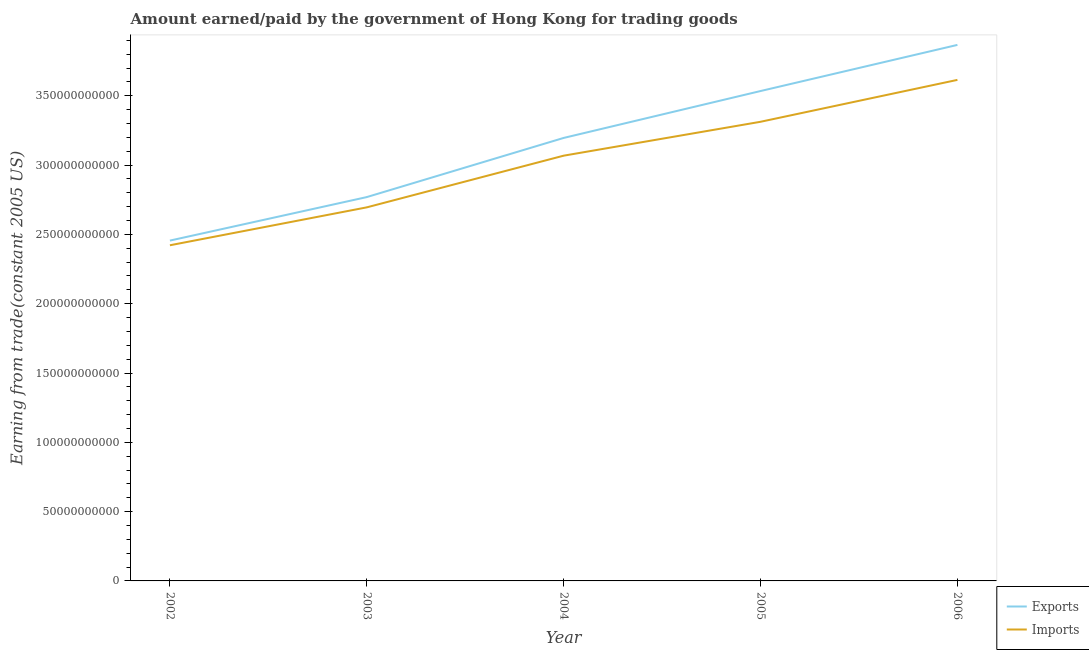How many different coloured lines are there?
Your response must be concise. 2. What is the amount paid for imports in 2004?
Provide a succinct answer. 3.07e+11. Across all years, what is the maximum amount earned from exports?
Your answer should be compact. 3.87e+11. Across all years, what is the minimum amount earned from exports?
Your answer should be compact. 2.46e+11. In which year was the amount earned from exports maximum?
Provide a succinct answer. 2006. What is the total amount paid for imports in the graph?
Offer a terse response. 1.51e+12. What is the difference between the amount paid for imports in 2004 and that in 2006?
Your answer should be compact. -5.47e+1. What is the difference between the amount paid for imports in 2003 and the amount earned from exports in 2002?
Your answer should be compact. 2.40e+1. What is the average amount paid for imports per year?
Ensure brevity in your answer.  3.02e+11. In the year 2006, what is the difference between the amount paid for imports and amount earned from exports?
Provide a succinct answer. -2.52e+1. In how many years, is the amount earned from exports greater than 330000000000 US$?
Offer a very short reply. 2. What is the ratio of the amount paid for imports in 2003 to that in 2004?
Keep it short and to the point. 0.88. Is the amount earned from exports in 2002 less than that in 2005?
Make the answer very short. Yes. What is the difference between the highest and the second highest amount paid for imports?
Ensure brevity in your answer.  3.02e+1. What is the difference between the highest and the lowest amount earned from exports?
Your response must be concise. 1.41e+11. Is the amount paid for imports strictly greater than the amount earned from exports over the years?
Make the answer very short. No. Is the amount earned from exports strictly less than the amount paid for imports over the years?
Ensure brevity in your answer.  No. How many lines are there?
Your response must be concise. 2. How many years are there in the graph?
Provide a succinct answer. 5. Are the values on the major ticks of Y-axis written in scientific E-notation?
Provide a short and direct response. No. Where does the legend appear in the graph?
Offer a very short reply. Bottom right. What is the title of the graph?
Provide a succinct answer. Amount earned/paid by the government of Hong Kong for trading goods. What is the label or title of the X-axis?
Provide a short and direct response. Year. What is the label or title of the Y-axis?
Offer a very short reply. Earning from trade(constant 2005 US). What is the Earning from trade(constant 2005 US) of Exports in 2002?
Offer a very short reply. 2.46e+11. What is the Earning from trade(constant 2005 US) in Imports in 2002?
Give a very brief answer. 2.42e+11. What is the Earning from trade(constant 2005 US) of Exports in 2003?
Keep it short and to the point. 2.77e+11. What is the Earning from trade(constant 2005 US) in Imports in 2003?
Offer a very short reply. 2.70e+11. What is the Earning from trade(constant 2005 US) of Exports in 2004?
Offer a terse response. 3.20e+11. What is the Earning from trade(constant 2005 US) of Imports in 2004?
Your answer should be very brief. 3.07e+11. What is the Earning from trade(constant 2005 US) of Exports in 2005?
Provide a short and direct response. 3.53e+11. What is the Earning from trade(constant 2005 US) of Imports in 2005?
Provide a short and direct response. 3.31e+11. What is the Earning from trade(constant 2005 US) in Exports in 2006?
Provide a succinct answer. 3.87e+11. What is the Earning from trade(constant 2005 US) in Imports in 2006?
Provide a succinct answer. 3.61e+11. Across all years, what is the maximum Earning from trade(constant 2005 US) of Exports?
Offer a terse response. 3.87e+11. Across all years, what is the maximum Earning from trade(constant 2005 US) in Imports?
Your answer should be very brief. 3.61e+11. Across all years, what is the minimum Earning from trade(constant 2005 US) in Exports?
Your answer should be compact. 2.46e+11. Across all years, what is the minimum Earning from trade(constant 2005 US) in Imports?
Give a very brief answer. 2.42e+11. What is the total Earning from trade(constant 2005 US) in Exports in the graph?
Your answer should be very brief. 1.58e+12. What is the total Earning from trade(constant 2005 US) of Imports in the graph?
Your response must be concise. 1.51e+12. What is the difference between the Earning from trade(constant 2005 US) in Exports in 2002 and that in 2003?
Your response must be concise. -3.14e+1. What is the difference between the Earning from trade(constant 2005 US) of Imports in 2002 and that in 2003?
Provide a short and direct response. -2.74e+1. What is the difference between the Earning from trade(constant 2005 US) in Exports in 2002 and that in 2004?
Make the answer very short. -7.41e+1. What is the difference between the Earning from trade(constant 2005 US) of Imports in 2002 and that in 2004?
Keep it short and to the point. -6.46e+1. What is the difference between the Earning from trade(constant 2005 US) in Exports in 2002 and that in 2005?
Offer a very short reply. -1.08e+11. What is the difference between the Earning from trade(constant 2005 US) in Imports in 2002 and that in 2005?
Provide a succinct answer. -8.91e+1. What is the difference between the Earning from trade(constant 2005 US) in Exports in 2002 and that in 2006?
Give a very brief answer. -1.41e+11. What is the difference between the Earning from trade(constant 2005 US) of Imports in 2002 and that in 2006?
Make the answer very short. -1.19e+11. What is the difference between the Earning from trade(constant 2005 US) of Exports in 2003 and that in 2004?
Your answer should be very brief. -4.27e+1. What is the difference between the Earning from trade(constant 2005 US) of Imports in 2003 and that in 2004?
Give a very brief answer. -3.73e+1. What is the difference between the Earning from trade(constant 2005 US) in Exports in 2003 and that in 2005?
Ensure brevity in your answer.  -7.65e+1. What is the difference between the Earning from trade(constant 2005 US) of Imports in 2003 and that in 2005?
Provide a succinct answer. -6.17e+1. What is the difference between the Earning from trade(constant 2005 US) in Exports in 2003 and that in 2006?
Your answer should be very brief. -1.10e+11. What is the difference between the Earning from trade(constant 2005 US) in Imports in 2003 and that in 2006?
Your response must be concise. -9.20e+1. What is the difference between the Earning from trade(constant 2005 US) of Exports in 2004 and that in 2005?
Your response must be concise. -3.38e+1. What is the difference between the Earning from trade(constant 2005 US) in Imports in 2004 and that in 2005?
Your answer should be very brief. -2.45e+1. What is the difference between the Earning from trade(constant 2005 US) in Exports in 2004 and that in 2006?
Keep it short and to the point. -6.71e+1. What is the difference between the Earning from trade(constant 2005 US) in Imports in 2004 and that in 2006?
Keep it short and to the point. -5.47e+1. What is the difference between the Earning from trade(constant 2005 US) in Exports in 2005 and that in 2006?
Keep it short and to the point. -3.33e+1. What is the difference between the Earning from trade(constant 2005 US) of Imports in 2005 and that in 2006?
Offer a very short reply. -3.02e+1. What is the difference between the Earning from trade(constant 2005 US) in Exports in 2002 and the Earning from trade(constant 2005 US) in Imports in 2003?
Your answer should be compact. -2.40e+1. What is the difference between the Earning from trade(constant 2005 US) in Exports in 2002 and the Earning from trade(constant 2005 US) in Imports in 2004?
Offer a very short reply. -6.13e+1. What is the difference between the Earning from trade(constant 2005 US) of Exports in 2002 and the Earning from trade(constant 2005 US) of Imports in 2005?
Ensure brevity in your answer.  -8.57e+1. What is the difference between the Earning from trade(constant 2005 US) of Exports in 2002 and the Earning from trade(constant 2005 US) of Imports in 2006?
Make the answer very short. -1.16e+11. What is the difference between the Earning from trade(constant 2005 US) of Exports in 2003 and the Earning from trade(constant 2005 US) of Imports in 2004?
Provide a short and direct response. -2.99e+1. What is the difference between the Earning from trade(constant 2005 US) of Exports in 2003 and the Earning from trade(constant 2005 US) of Imports in 2005?
Ensure brevity in your answer.  -5.43e+1. What is the difference between the Earning from trade(constant 2005 US) of Exports in 2003 and the Earning from trade(constant 2005 US) of Imports in 2006?
Your answer should be very brief. -8.45e+1. What is the difference between the Earning from trade(constant 2005 US) in Exports in 2004 and the Earning from trade(constant 2005 US) in Imports in 2005?
Provide a short and direct response. -1.17e+1. What is the difference between the Earning from trade(constant 2005 US) of Exports in 2004 and the Earning from trade(constant 2005 US) of Imports in 2006?
Give a very brief answer. -4.19e+1. What is the difference between the Earning from trade(constant 2005 US) of Exports in 2005 and the Earning from trade(constant 2005 US) of Imports in 2006?
Offer a terse response. -8.04e+09. What is the average Earning from trade(constant 2005 US) of Exports per year?
Offer a terse response. 3.16e+11. What is the average Earning from trade(constant 2005 US) in Imports per year?
Provide a short and direct response. 3.02e+11. In the year 2002, what is the difference between the Earning from trade(constant 2005 US) in Exports and Earning from trade(constant 2005 US) in Imports?
Make the answer very short. 3.38e+09. In the year 2003, what is the difference between the Earning from trade(constant 2005 US) of Exports and Earning from trade(constant 2005 US) of Imports?
Provide a succinct answer. 7.41e+09. In the year 2004, what is the difference between the Earning from trade(constant 2005 US) of Exports and Earning from trade(constant 2005 US) of Imports?
Keep it short and to the point. 1.28e+1. In the year 2005, what is the difference between the Earning from trade(constant 2005 US) of Exports and Earning from trade(constant 2005 US) of Imports?
Make the answer very short. 2.22e+1. In the year 2006, what is the difference between the Earning from trade(constant 2005 US) in Exports and Earning from trade(constant 2005 US) in Imports?
Provide a succinct answer. 2.52e+1. What is the ratio of the Earning from trade(constant 2005 US) in Exports in 2002 to that in 2003?
Your answer should be compact. 0.89. What is the ratio of the Earning from trade(constant 2005 US) in Imports in 2002 to that in 2003?
Give a very brief answer. 0.9. What is the ratio of the Earning from trade(constant 2005 US) of Exports in 2002 to that in 2004?
Provide a succinct answer. 0.77. What is the ratio of the Earning from trade(constant 2005 US) of Imports in 2002 to that in 2004?
Offer a very short reply. 0.79. What is the ratio of the Earning from trade(constant 2005 US) of Exports in 2002 to that in 2005?
Your answer should be compact. 0.69. What is the ratio of the Earning from trade(constant 2005 US) of Imports in 2002 to that in 2005?
Provide a short and direct response. 0.73. What is the ratio of the Earning from trade(constant 2005 US) of Exports in 2002 to that in 2006?
Offer a terse response. 0.63. What is the ratio of the Earning from trade(constant 2005 US) in Imports in 2002 to that in 2006?
Your answer should be very brief. 0.67. What is the ratio of the Earning from trade(constant 2005 US) in Exports in 2003 to that in 2004?
Ensure brevity in your answer.  0.87. What is the ratio of the Earning from trade(constant 2005 US) in Imports in 2003 to that in 2004?
Your answer should be very brief. 0.88. What is the ratio of the Earning from trade(constant 2005 US) of Exports in 2003 to that in 2005?
Ensure brevity in your answer.  0.78. What is the ratio of the Earning from trade(constant 2005 US) of Imports in 2003 to that in 2005?
Offer a terse response. 0.81. What is the ratio of the Earning from trade(constant 2005 US) of Exports in 2003 to that in 2006?
Ensure brevity in your answer.  0.72. What is the ratio of the Earning from trade(constant 2005 US) in Imports in 2003 to that in 2006?
Provide a short and direct response. 0.75. What is the ratio of the Earning from trade(constant 2005 US) of Exports in 2004 to that in 2005?
Give a very brief answer. 0.9. What is the ratio of the Earning from trade(constant 2005 US) of Imports in 2004 to that in 2005?
Your answer should be compact. 0.93. What is the ratio of the Earning from trade(constant 2005 US) in Exports in 2004 to that in 2006?
Your answer should be compact. 0.83. What is the ratio of the Earning from trade(constant 2005 US) of Imports in 2004 to that in 2006?
Offer a terse response. 0.85. What is the ratio of the Earning from trade(constant 2005 US) of Exports in 2005 to that in 2006?
Provide a succinct answer. 0.91. What is the ratio of the Earning from trade(constant 2005 US) in Imports in 2005 to that in 2006?
Keep it short and to the point. 0.92. What is the difference between the highest and the second highest Earning from trade(constant 2005 US) in Exports?
Ensure brevity in your answer.  3.33e+1. What is the difference between the highest and the second highest Earning from trade(constant 2005 US) in Imports?
Provide a succinct answer. 3.02e+1. What is the difference between the highest and the lowest Earning from trade(constant 2005 US) of Exports?
Make the answer very short. 1.41e+11. What is the difference between the highest and the lowest Earning from trade(constant 2005 US) of Imports?
Give a very brief answer. 1.19e+11. 